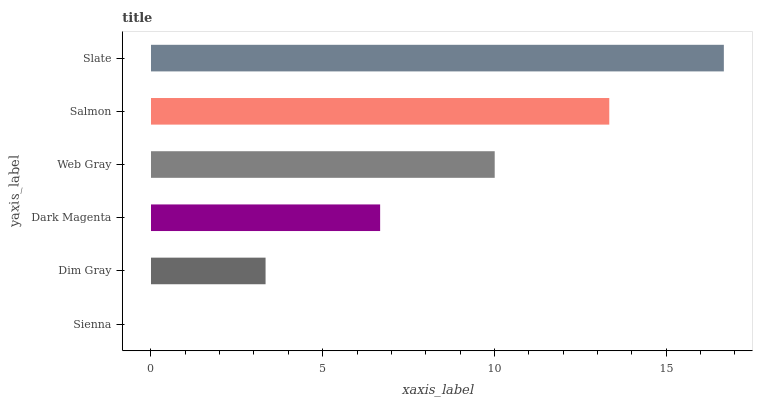Is Sienna the minimum?
Answer yes or no. Yes. Is Slate the maximum?
Answer yes or no. Yes. Is Dim Gray the minimum?
Answer yes or no. No. Is Dim Gray the maximum?
Answer yes or no. No. Is Dim Gray greater than Sienna?
Answer yes or no. Yes. Is Sienna less than Dim Gray?
Answer yes or no. Yes. Is Sienna greater than Dim Gray?
Answer yes or no. No. Is Dim Gray less than Sienna?
Answer yes or no. No. Is Web Gray the high median?
Answer yes or no. Yes. Is Dark Magenta the low median?
Answer yes or no. Yes. Is Dim Gray the high median?
Answer yes or no. No. Is Web Gray the low median?
Answer yes or no. No. 